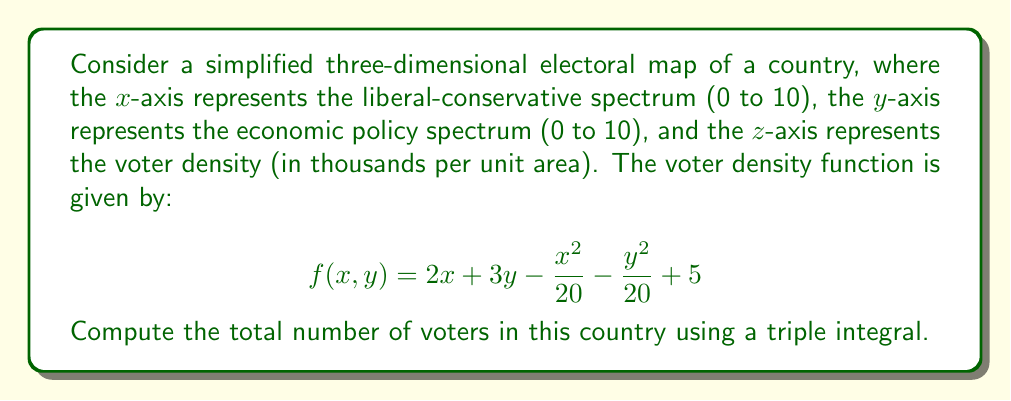Give your solution to this math problem. To solve this problem, we need to follow these steps:

1) The given function f(x,y) represents the voter density in thousands per unit area. To find the total number of voters, we need to integrate this function over the entire region.

2) The region is defined as 0 ≤ x ≤ 10 and 0 ≤ y ≤ 10.

3) We'll set up a triple integral. Since the density function doesn't depend on z, we can treat this as a double integral and multiply by the height (which is 1 in this case, as we're dealing with density per unit area).

4) The integral will be:

   $$\int_0^{10} \int_0^{10} f(x,y) \, dy \, dx$$

5) Substituting the function:

   $$\int_0^{10} \int_0^{10} (2x + 3y - \frac{x^2}{20} - \frac{y^2}{20} + 5) \, dy \, dx$$

6) Let's integrate with respect to y first:

   $$\int_0^{10} \left[2xy + \frac{3y^2}{2} - \frac{x^2y}{20} - \frac{y^3}{60} + 5y\right]_0^{10} \, dx$$

7) Evaluating the inner integral:

   $$\int_0^{10} (20x + 150 - 5x^2 - \frac{1000}{6} + 50) \, dx$$

8) Simplifying:

   $$\int_0^{10} (20x - 5x^2 + \frac{1000}{3}) \, dx$$

9) Now integrate with respect to x:

   $$\left[10x^2 - \frac{5x^3}{3} + \frac{1000x}{3}\right]_0^{10}$$

10) Evaluating at the limits:

    $$(1000 - \frac{5000}{3} + \frac{10000}{3}) - (0)$$

11) Simplifying:

    $$\frac{14000}{3} \approx 4666.67$$

12) Remember, this result is in thousands. So the actual number of voters is:

    4666.67 * 1000 = 4,666,670
Answer: 4,666,670 voters 